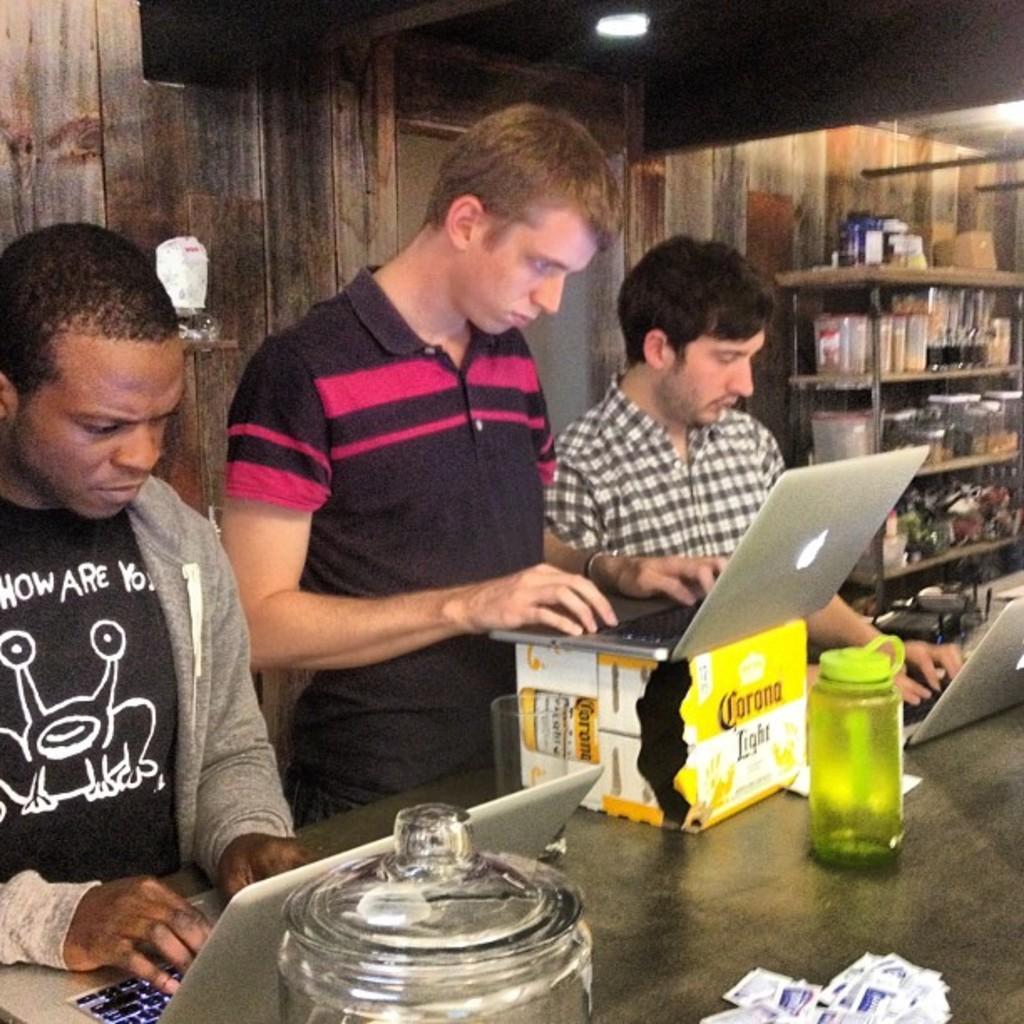Please provide a concise description of this image. In this image few people are behind the table having a bottle, jar, box, laptops and few objects. On the box there is a laptop. Middle of the image there is a person operating the laptop. Right side there is a rack having few objects in it. Top of the image there are few lights attached to the roof. 